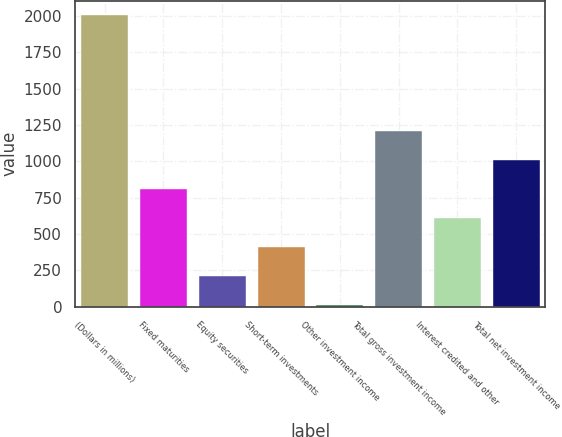Convert chart. <chart><loc_0><loc_0><loc_500><loc_500><bar_chart><fcel>(Dollars in millions)<fcel>Fixed maturities<fcel>Equity securities<fcel>Short-term investments<fcel>Other investment income<fcel>Total gross investment income<fcel>Interest credited and other<fcel>Total net investment income<nl><fcel>2005<fcel>810.76<fcel>213.64<fcel>412.68<fcel>14.6<fcel>1208.84<fcel>611.72<fcel>1009.8<nl></chart> 